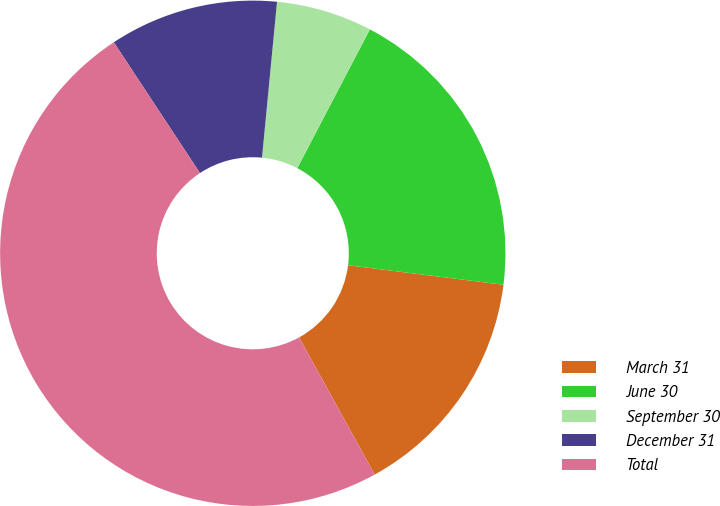Convert chart. <chart><loc_0><loc_0><loc_500><loc_500><pie_chart><fcel>March 31<fcel>June 30<fcel>September 30<fcel>December 31<fcel>Total<nl><fcel>15.0%<fcel>19.32%<fcel>6.14%<fcel>10.8%<fcel>48.75%<nl></chart> 